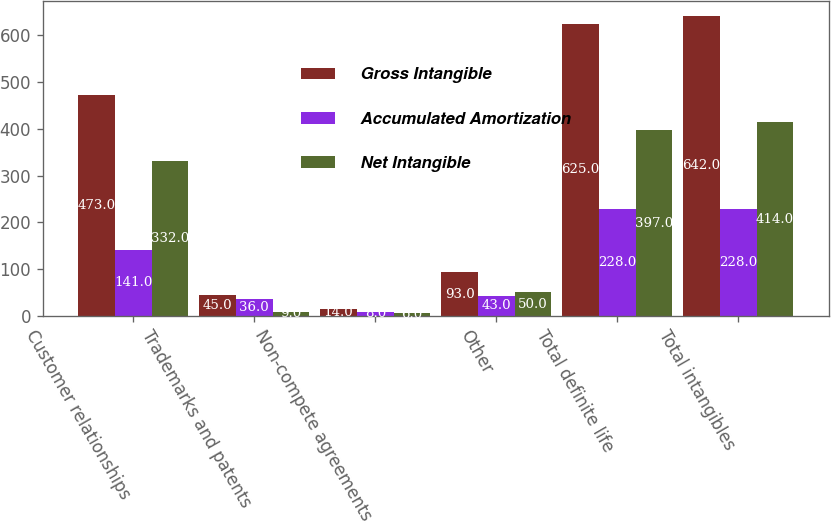<chart> <loc_0><loc_0><loc_500><loc_500><stacked_bar_chart><ecel><fcel>Customer relationships<fcel>Trademarks and patents<fcel>Non-compete agreements<fcel>Other<fcel>Total definite life<fcel>Total intangibles<nl><fcel>Gross Intangible<fcel>473<fcel>45<fcel>14<fcel>93<fcel>625<fcel>642<nl><fcel>Accumulated Amortization<fcel>141<fcel>36<fcel>8<fcel>43<fcel>228<fcel>228<nl><fcel>Net Intangible<fcel>332<fcel>9<fcel>6<fcel>50<fcel>397<fcel>414<nl></chart> 